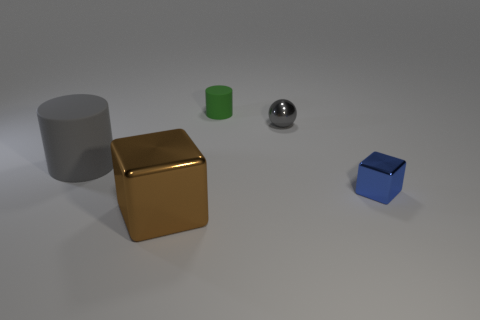Subtract all cylinders. How many objects are left? 3 Subtract 1 cylinders. How many cylinders are left? 1 Subtract all red cubes. Subtract all blue cylinders. How many cubes are left? 2 Subtract all green cubes. How many green cylinders are left? 1 Subtract all tiny brown shiny cubes. Subtract all brown shiny blocks. How many objects are left? 4 Add 5 small blue metallic things. How many small blue metallic things are left? 6 Add 5 blue spheres. How many blue spheres exist? 5 Add 1 tiny green matte things. How many objects exist? 6 Subtract all brown blocks. How many blocks are left? 1 Subtract 0 brown balls. How many objects are left? 5 